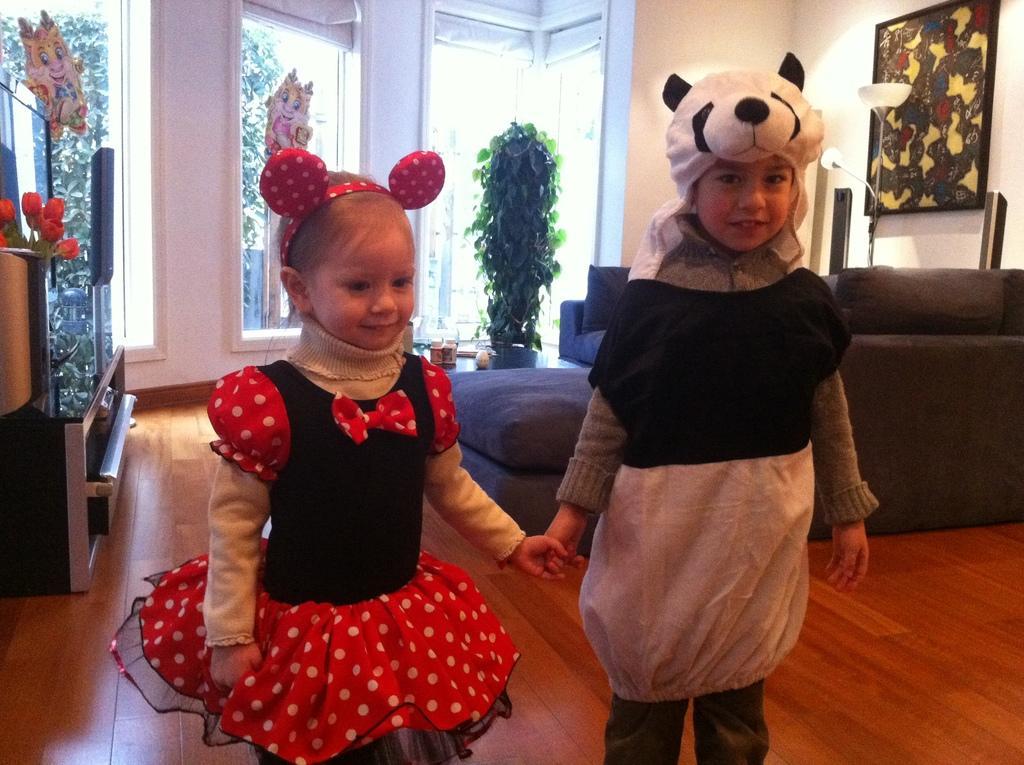Can you describe this image briefly? In this image we can see children standing on the floor and dressed in costumes. In the background there are wall hanging to the wall, sofa set, creepers, houseplant, cartoon stickers pasted on the mirror and a vase. 